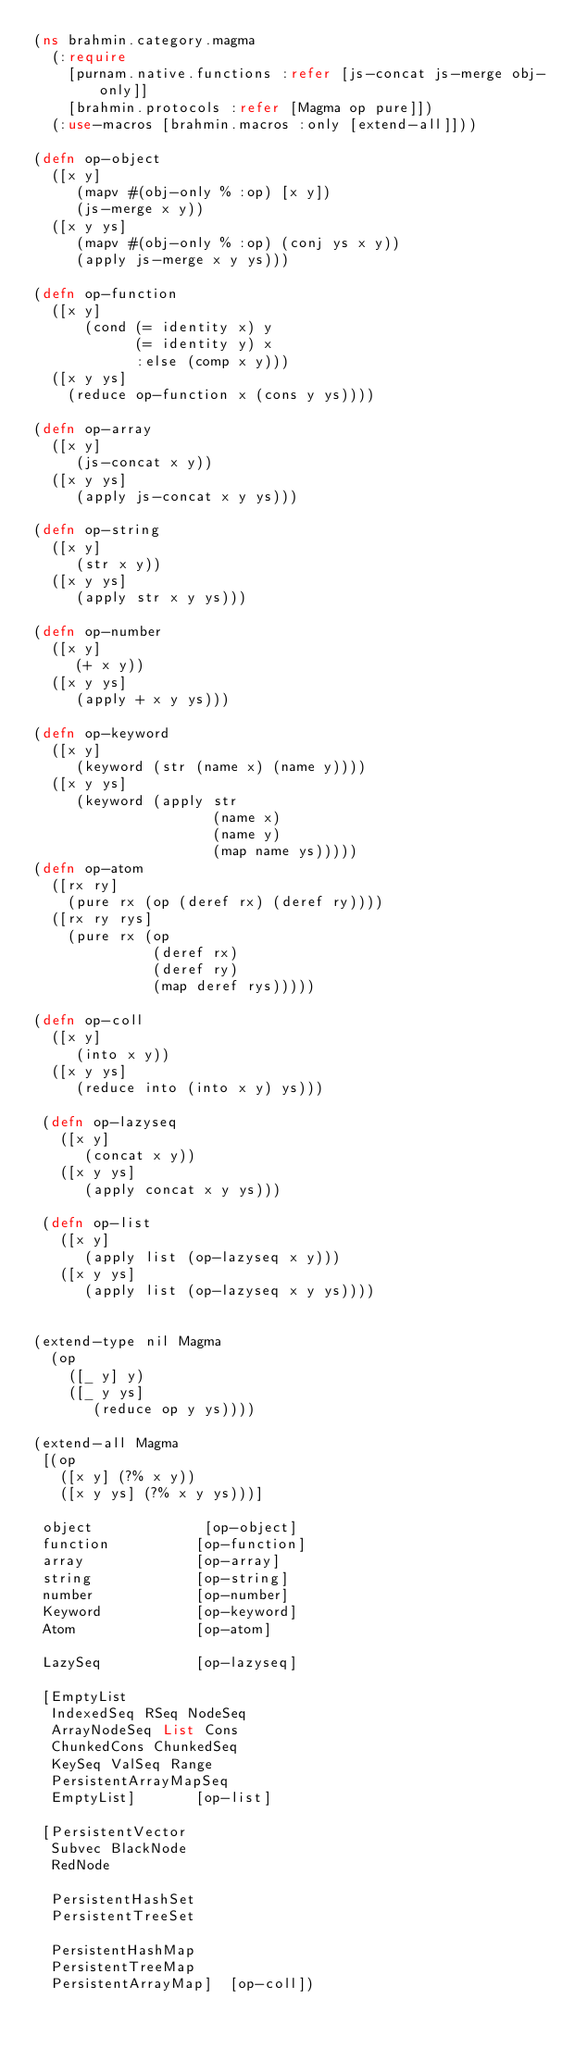Convert code to text. <code><loc_0><loc_0><loc_500><loc_500><_Clojure_>(ns brahmin.category.magma
  (:require
    [purnam.native.functions :refer [js-concat js-merge obj-only]]
    [brahmin.protocols :refer [Magma op pure]])
  (:use-macros [brahmin.macros :only [extend-all]]))

(defn op-object
  ([x y]
     (mapv #(obj-only % :op) [x y])
     (js-merge x y))
  ([x y ys]
     (mapv #(obj-only % :op) (conj ys x y))
     (apply js-merge x y ys)))

(defn op-function
  ([x y]
      (cond (= identity x) y
            (= identity y) x
            :else (comp x y)))
  ([x y ys]
    (reduce op-function x (cons y ys))))

(defn op-array
  ([x y]
     (js-concat x y))
  ([x y ys]
     (apply js-concat x y ys)))

(defn op-string
  ([x y]
     (str x y))
  ([x y ys]
     (apply str x y ys)))

(defn op-number
  ([x y]
     (+ x y))
  ([x y ys]
     (apply + x y ys)))

(defn op-keyword
  ([x y]
     (keyword (str (name x) (name y))))
  ([x y ys]
     (keyword (apply str
                     (name x)
                     (name y)
                     (map name ys)))))
(defn op-atom
  ([rx ry]
    (pure rx (op (deref rx) (deref ry))))
  ([rx ry rys]
    (pure rx (op
              (deref rx)
              (deref ry)
              (map deref rys)))))

(defn op-coll
  ([x y]
     (into x y))
  ([x y ys]
     (reduce into (into x y) ys)))

 (defn op-lazyseq
   ([x y]
      (concat x y))
   ([x y ys]
      (apply concat x y ys)))

 (defn op-list
   ([x y]
      (apply list (op-lazyseq x y)))
   ([x y ys]
      (apply list (op-lazyseq x y ys))))


(extend-type nil Magma
  (op
    ([_ y] y)
    ([_ y ys]
       (reduce op y ys))))

(extend-all Magma
 [(op
   ([x y] (?% x y))
   ([x y ys] (?% x y ys)))]

 object             [op-object]
 function          [op-function]
 array             [op-array]
 string            [op-string]
 number            [op-number]
 Keyword           [op-keyword]
 Atom              [op-atom]

 LazySeq           [op-lazyseq]

 [EmptyList
  IndexedSeq RSeq NodeSeq
  ArrayNodeSeq List Cons
  ChunkedCons ChunkedSeq
  KeySeq ValSeq Range
  PersistentArrayMapSeq
  EmptyList]       [op-list]

 [PersistentVector
  Subvec BlackNode
  RedNode

  PersistentHashSet
  PersistentTreeSet

  PersistentHashMap
  PersistentTreeMap
  PersistentArrayMap]  [op-coll])
</code> 